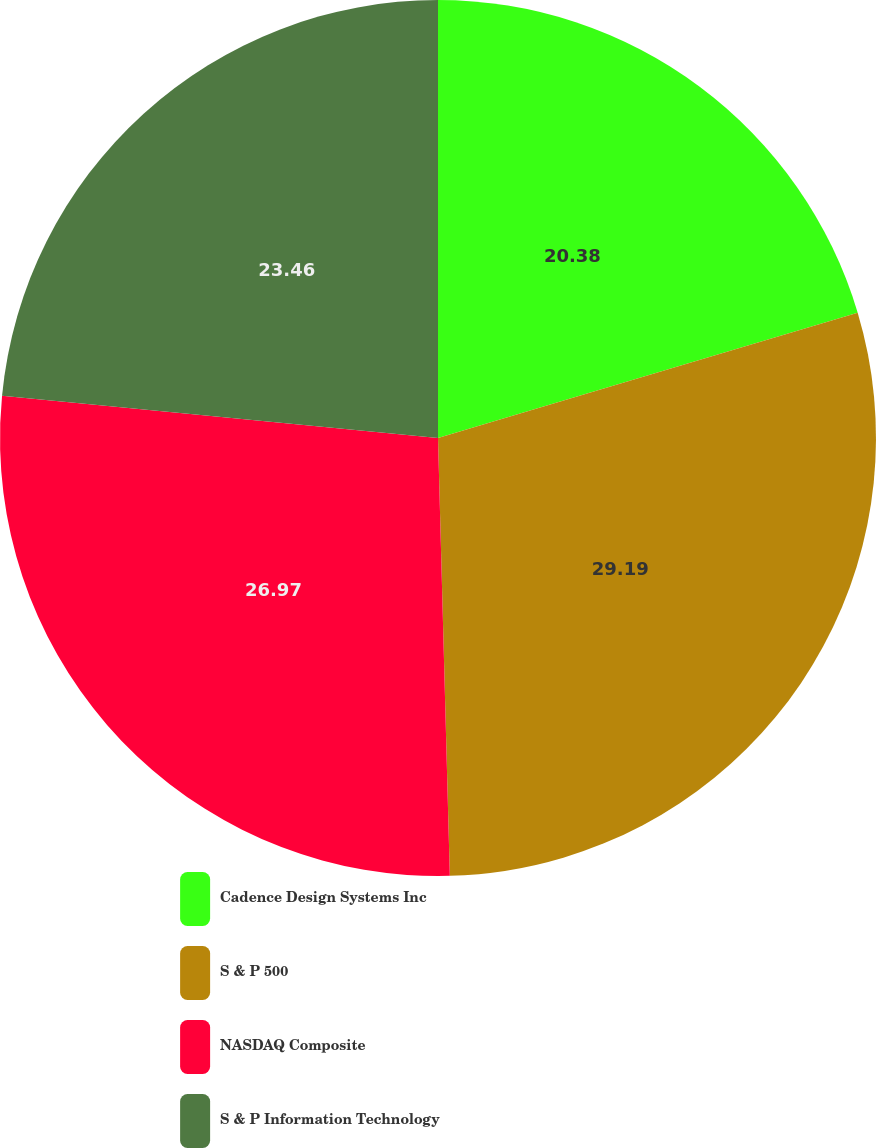Convert chart. <chart><loc_0><loc_0><loc_500><loc_500><pie_chart><fcel>Cadence Design Systems Inc<fcel>S & P 500<fcel>NASDAQ Composite<fcel>S & P Information Technology<nl><fcel>20.38%<fcel>29.19%<fcel>26.97%<fcel>23.46%<nl></chart> 